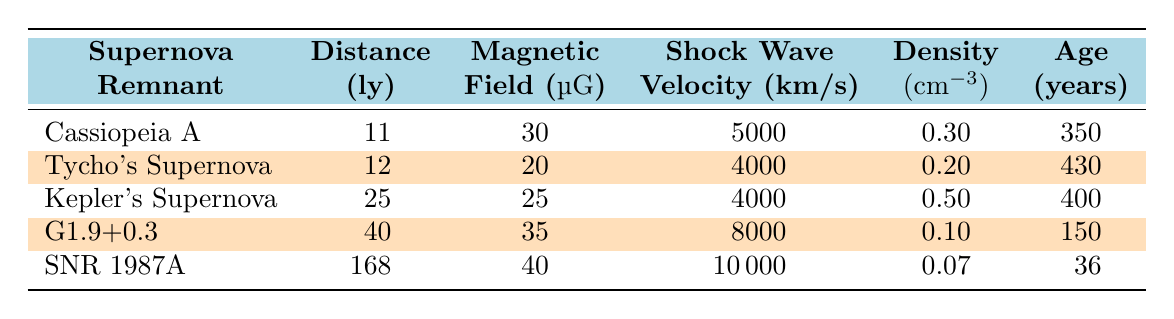What is the magnetic field strength of SNR 1987A? Referring to the table, SNR 1987A has a magnetic field strength listed as 40 micro Gauss.
Answer: 40 micro Gauss Which supernova remnant has the highest shock wave velocity? By comparing the shock wave velocity values in the table, SNR 1987A has the highest velocity of 10000 km/s, while G1.9+0.3 has the second highest at 8000 km/s.
Answer: SNR 1987A Is the density of Tycho's Supernova greater than that of Cassiopeia A? Looking at the density values, Tycho's Supernova has a density of 0.20 cm3, and Cassiopeia A has a density of 0.30 cm3. Since 0.20 is less than 0.30, the statement is false.
Answer: No What is the average magnetic field strength of the supernova remnants in the table? To find the average, we sum the magnetic field strengths of all remnants: 30 + 20 + 25 + 35 + 40 = 150. There are 5 supernova remnants, so we divide 150 by 5 to get an average of 30 micro Gauss.
Answer: 30 micro Gauss Which supernova remnant is the oldest? The ages listed show SNR 1987A has the lowest age of 36 years and the oldest remnant is Tycho's Supernova, which is 430 years old. Thus, Tycho's Supernova is the oldest.
Answer: Tycho's Supernova Is the density of G1.9+0.3 lower than SNR 1987A? G1.9+0.3 has a density of 0.10 cm3, while SNR 1987A has a density of 0.07 cm3. Since 0.10 is greater than 0.07, the statement is false.
Answer: No What is the distance of Kepler's Supernova and how does it compare to Cassiopeia A's distance? The table shows Kepler's Supernova is 25 light years away, while Cassiopeia A is 11 light years away. Thus, Kepler's Supernova is farther away than Cassiopeia A.
Answer: 25 light years Which supernova remnant has the lowest magnetic field strength and what is that strength? The table indicates that Tycho's Supernova has the lowest magnetic field strength at 20 micro Gauss, lower than the others listed.
Answer: Tycho's Supernova, 20 micro Gauss What is the difference in shock wave velocity between Cassiopeia A and G1.9+0.3? Cassiopeia A has a shock wave velocity of 5000 km/s, and G1.9+0.3 has 8000 km/s. The difference is 8000 - 5000 = 3000 km/s.
Answer: 3000 km/s 